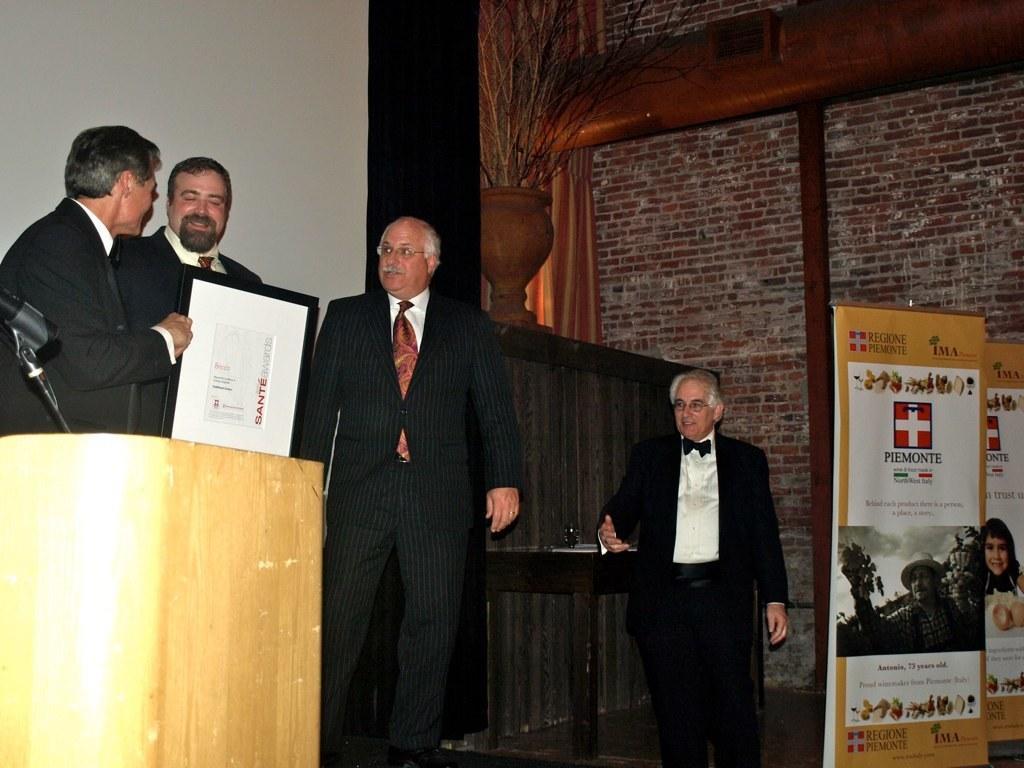Could you give a brief overview of what you see in this image? In this image there are three people standing on the dais and there is another person below the dais, beside that person there are two posters, behind the posters there is a brick wall. 